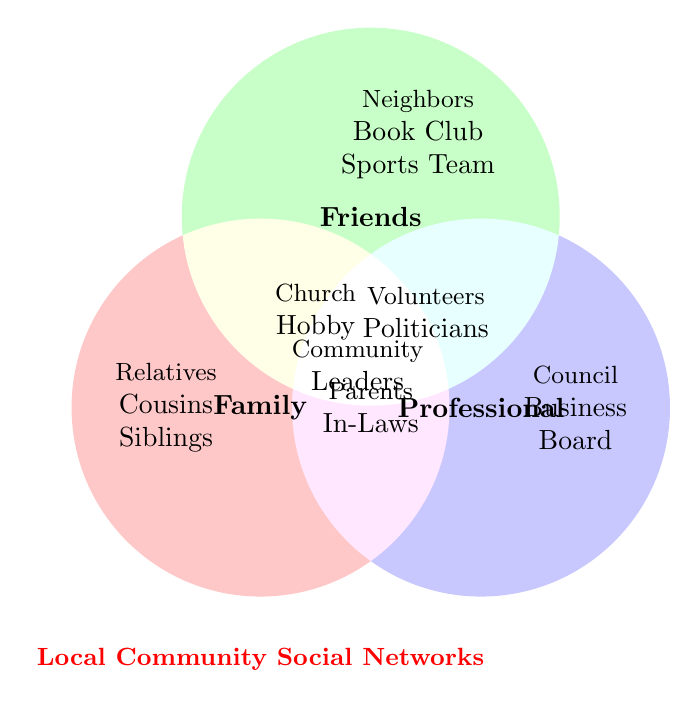what is the title of the Venn Diagram? The title is located at the bottom of the diagram and is written in red font. The title is "Local Community Social Networks".
Answer: Local Community Social Networks Which groups belong to the "Professional" network? "Professional" network corresponds to the circle on the right side of the Venn Diagram. The groups listed here are City Council Members, Local Business Owners, School Board, Non-Profit Directors, Chamber of Commerce, Local Politicians, and Civic Association Members.
Answer: City Council Members, Local Business Owners, School Board, Non-Profit Directors, Chamber of Commerce, Local Politicians, Civic Association Members How many unique groups are listed under the "Friends" network? The "Friends" network corresponds to the top circle. By counting the different groups listed, we have Neighbors, Book Club, Sports Team, Church Group, Hobby Group, Childhood Friends, and College Roommates, making a total of 7 unique groups.
Answer: 7 What groups fall under both "Family" and "Professional"? The groups that fall under both "Family" and "Professional" can be identified from the overlapping area between the "Family" and "Professional" circles. These are "Parents" and "In-Laws".
Answer: Parents, In-Laws Which groups are shared between "Friends" and "Professional" networks? The shared groups between "Friends" and "Professional" are located in the overlapping area of the "Friends" and "Professional" circles. Therefore, the groups are Community Volunteers and Local Politicians.
Answer: Community Volunteers, Local Politicians Name a group that is only in the "Professional" network and does not overlap with any other network. A group solely in the "Professional" network can be identified within the right circle without any overlaps. These groups are City Council Members, Local Business Owners, School Board, Non-Profit Directors, and Chamber of Commerce.
Answer: City Council Members, Local Business Owners, School Board, Non-Profit Directors, Chamber of Commerce List any groups that are common among "Family", "Friends", and "Professional" networks. The groups common among all three networks are located at the intersection of all three circles. The group listed here is Community Leaders.
Answer: Community Leaders What group(s) fall under both "Family" and "Friends"? The groups that fall under both "Family" and "Friends" can be found in the overlapping area between the "Family" and "Friends" circles. This includes Church Group and Hobby Group.
Answer: Church Group, Hobby Group 